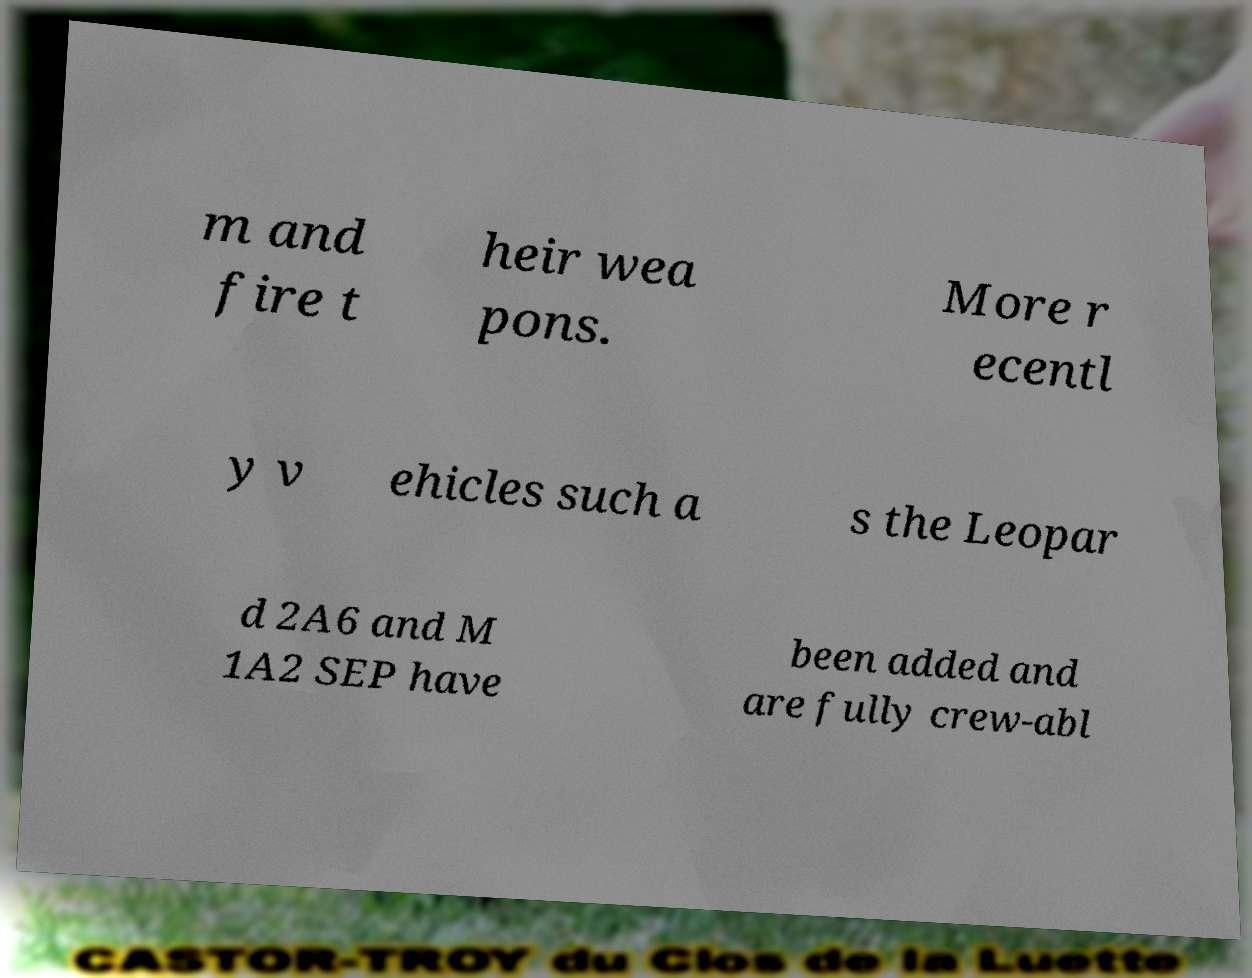Could you assist in decoding the text presented in this image and type it out clearly? m and fire t heir wea pons. More r ecentl y v ehicles such a s the Leopar d 2A6 and M 1A2 SEP have been added and are fully crew-abl 